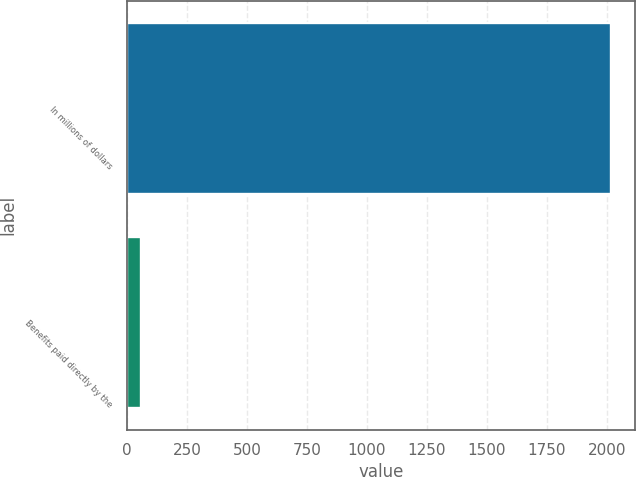Convert chart to OTSL. <chart><loc_0><loc_0><loc_500><loc_500><bar_chart><fcel>In millions of dollars<fcel>Benefits paid directly by the<nl><fcel>2018<fcel>60<nl></chart> 